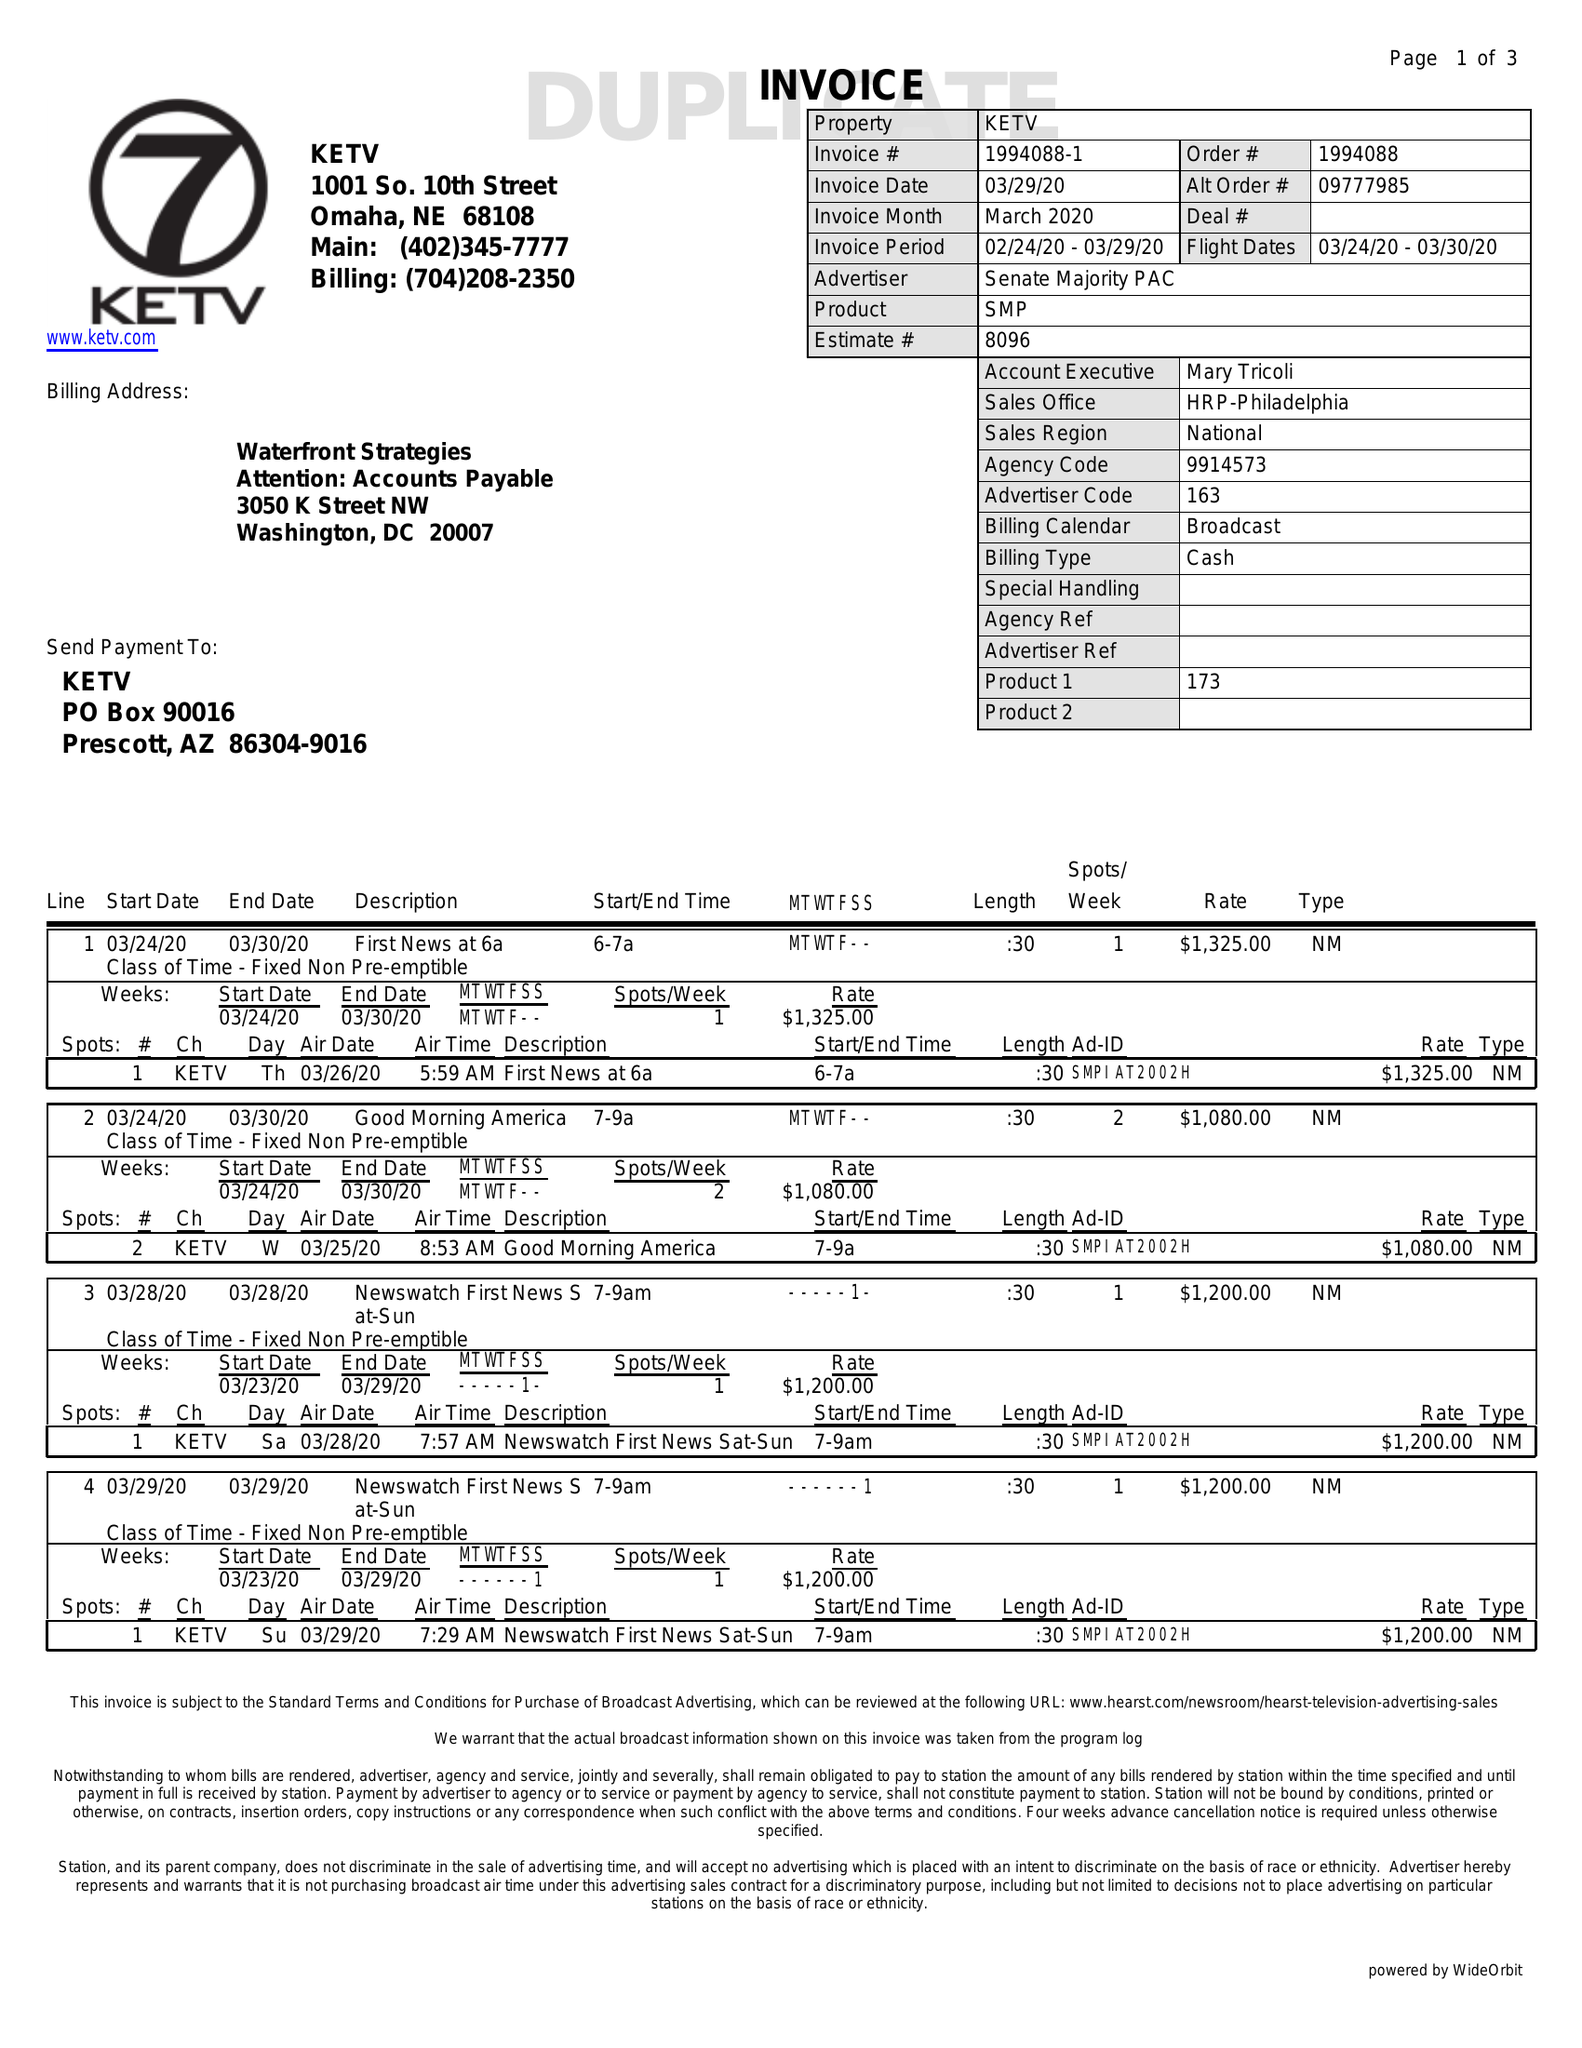What is the value for the flight_from?
Answer the question using a single word or phrase. 03/24/20 